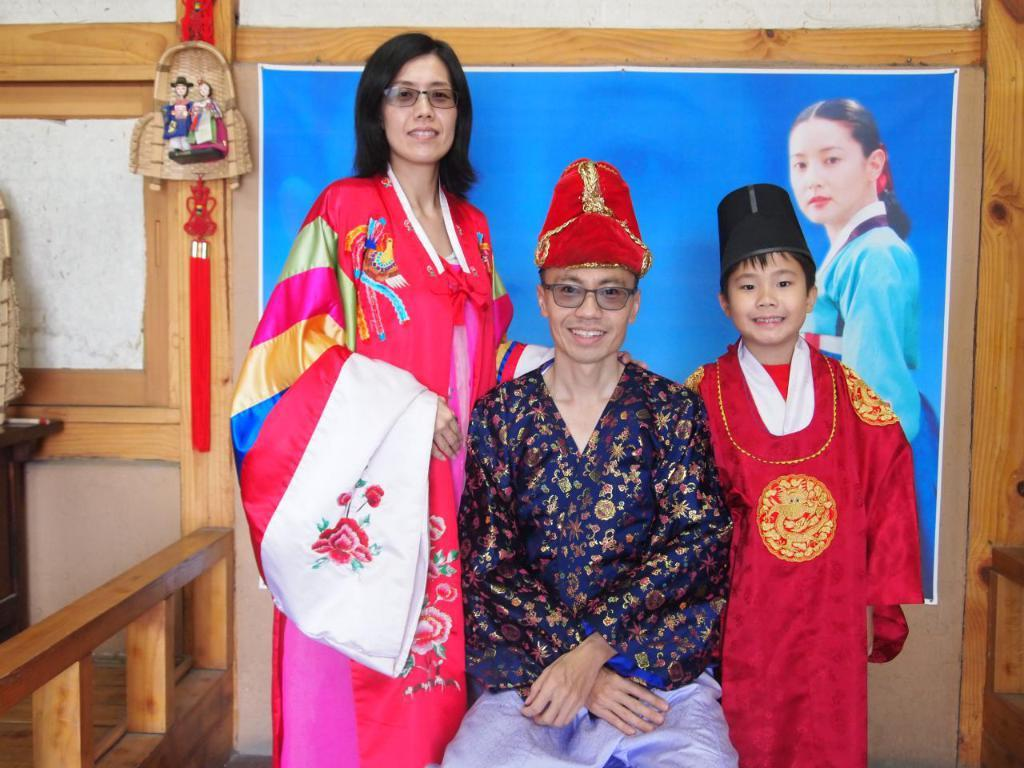How many people are in the foreground of the image? There are three people in the foreground of the image. What expressions do the people have? The people are smiling. What can be seen in the background of the image? There is a wooden object in the background of the image. What architectural feature is present on the left side of the image? There is a wooden fence on the left side of the image. What type of marble is being used to build the zoo in the image? There is no zoo or marble present in the image; it features three people smiling and a wooden fence on the left side. 